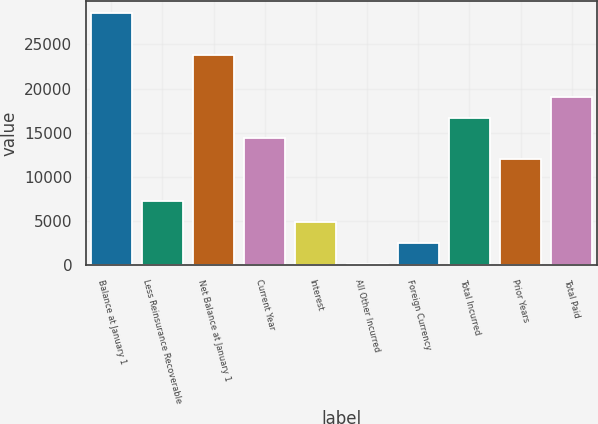Convert chart to OTSL. <chart><loc_0><loc_0><loc_500><loc_500><bar_chart><fcel>Balance at January 1<fcel>Less Reinsurance Recoverable<fcel>Net Balance at January 1<fcel>Current Year<fcel>Interest<fcel>All Other Incurred<fcel>Foreign Currency<fcel>Total Incurred<fcel>Prior Years<fcel>Total Paid<nl><fcel>28515.7<fcel>7277.64<fcel>23796.1<fcel>14357<fcel>4917.86<fcel>198.3<fcel>2558.08<fcel>16716.8<fcel>11997.2<fcel>19076.5<nl></chart> 